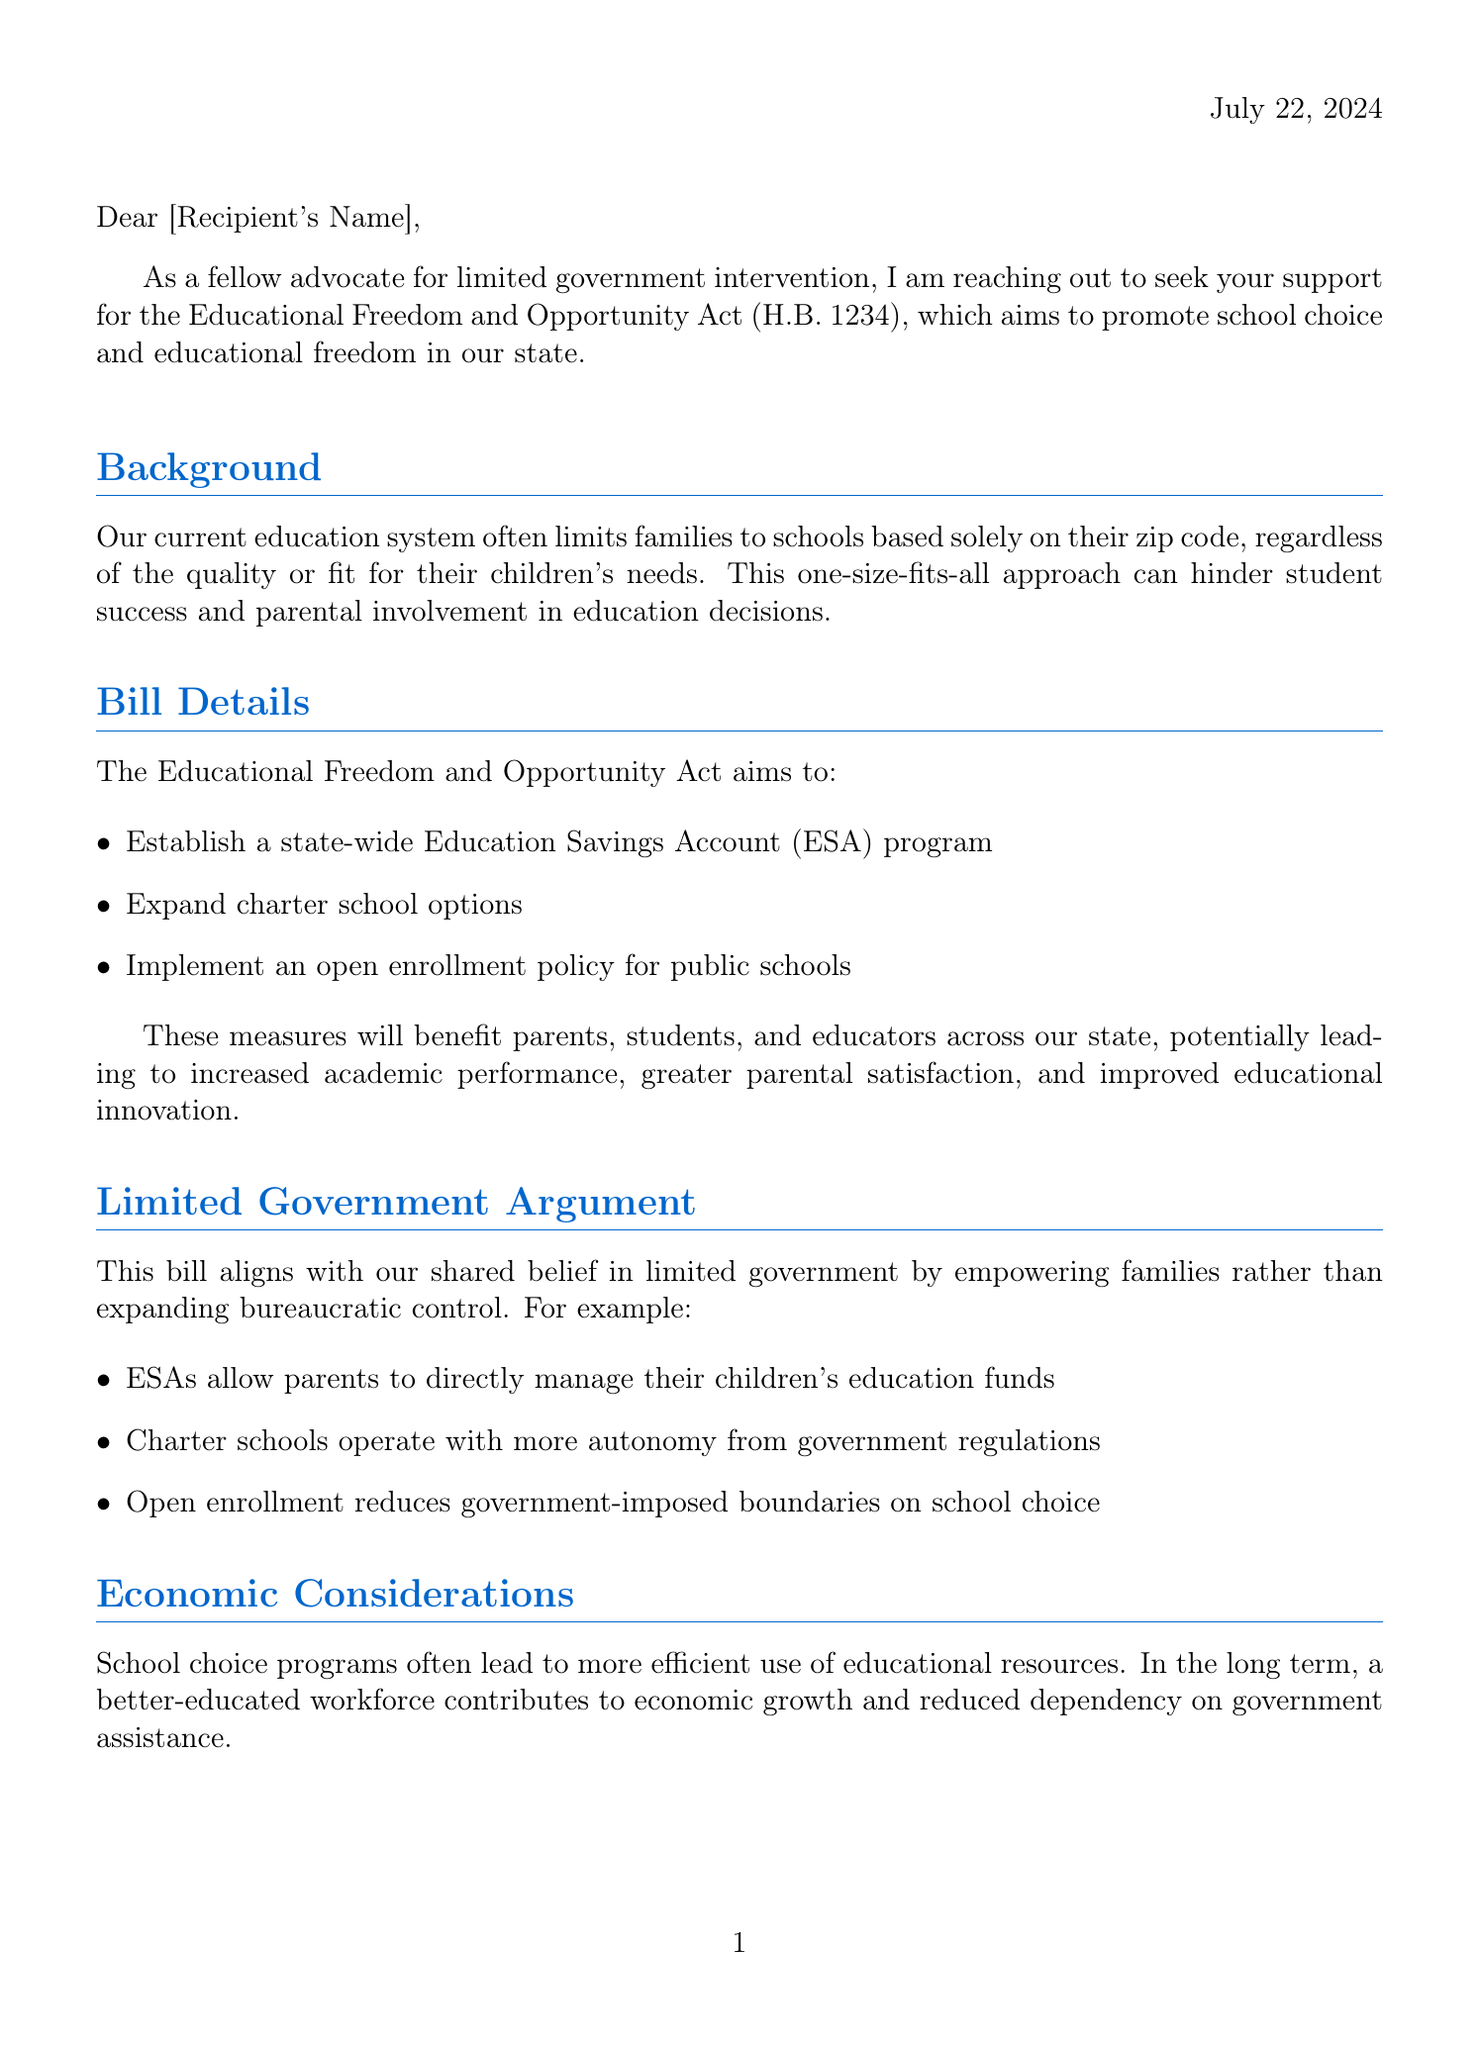What is the bill number? The bill number mentioned in the document is specified in the title of the act.
Answer: H.B. 1234 What does the Educational Freedom and Opportunity Act aim to establish? The main objectives of the bill include establishing a state-wide Education Savings Account program.
Answer: Education Savings Account (ESA) program Who are the beneficiaries of this bill? The beneficiaries of the bill are listed within the bill details section of the document.
Answer: Parents, students, and educators What does ESA allow parents to do? The document explains that ESAs give parents the ability to manage their children's education funds directly.
Answer: Manage their children's education funds What are the economic benefits of school choice mentioned? The document states that school choice programs lead to more efficient use of educational resources.
Answer: More efficient use of educational resources What is the call to action in the letter? The call to action explicitly requests the recipient to support and co-sponsor the bill.
Answer: Support in co-sponsoring H.B. 1234 Who is endorsing the educational reforms? The document includes endorsements from experts, highlighting their support for educational reforms.
Answer: Dr. Patrick Wolf, Dr. Susan Aud What is stated about bipartisan appeal? The document discusses that the bill has the potential to garner support from both Democrats and Republicans.
Answer: Support across party lines What primary principle does the bill align with? The document refers to a specific principle that the bill embodies related to government intervention.
Answer: Limited government 